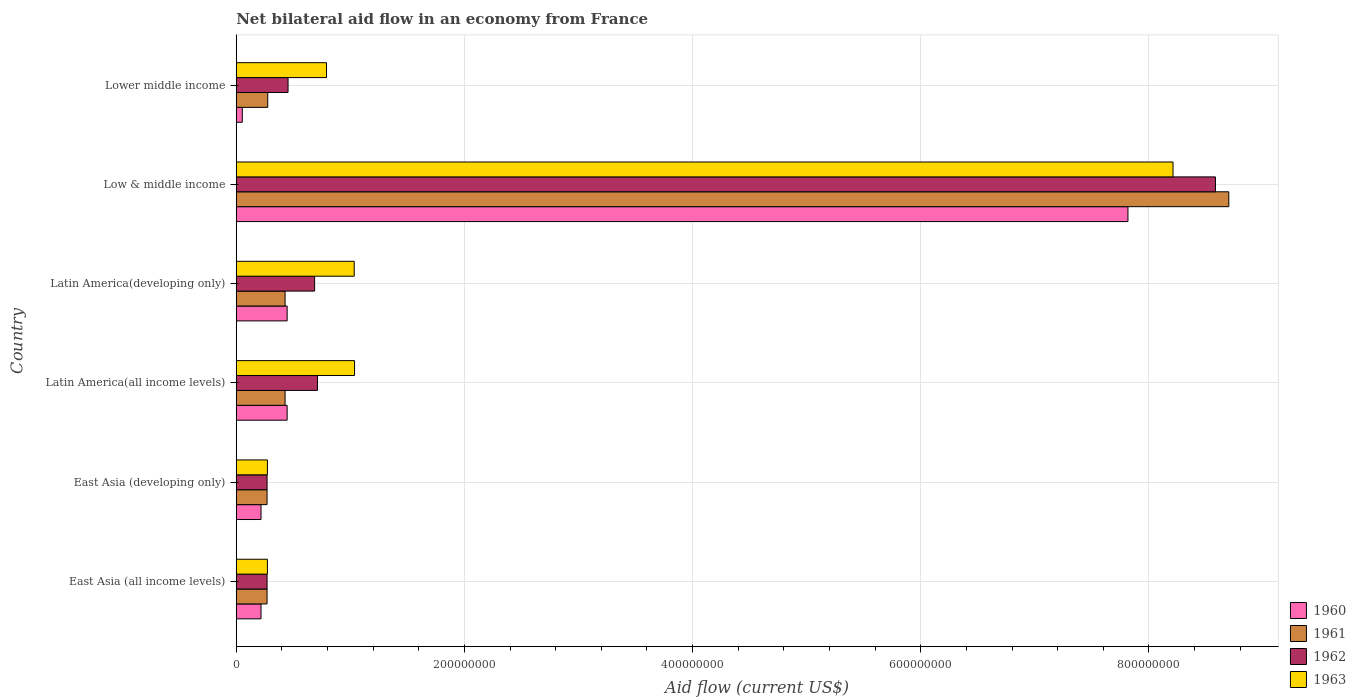Are the number of bars per tick equal to the number of legend labels?
Keep it short and to the point. Yes. Are the number of bars on each tick of the Y-axis equal?
Offer a very short reply. Yes. How many bars are there on the 2nd tick from the top?
Ensure brevity in your answer.  4. What is the label of the 6th group of bars from the top?
Your response must be concise. East Asia (all income levels). What is the net bilateral aid flow in 1960 in Latin America(developing only)?
Ensure brevity in your answer.  4.46e+07. Across all countries, what is the maximum net bilateral aid flow in 1963?
Make the answer very short. 8.21e+08. Across all countries, what is the minimum net bilateral aid flow in 1963?
Give a very brief answer. 2.73e+07. In which country was the net bilateral aid flow in 1962 maximum?
Keep it short and to the point. Low & middle income. In which country was the net bilateral aid flow in 1962 minimum?
Keep it short and to the point. East Asia (all income levels). What is the total net bilateral aid flow in 1960 in the graph?
Make the answer very short. 9.20e+08. What is the difference between the net bilateral aid flow in 1963 in Latin America(all income levels) and that in Latin America(developing only)?
Keep it short and to the point. 3.00e+05. What is the difference between the net bilateral aid flow in 1963 in Latin America(all income levels) and the net bilateral aid flow in 1961 in East Asia (developing only)?
Ensure brevity in your answer.  7.67e+07. What is the average net bilateral aid flow in 1961 per country?
Offer a terse response. 1.73e+08. What is the difference between the net bilateral aid flow in 1963 and net bilateral aid flow in 1960 in East Asia (all income levels)?
Your answer should be very brief. 5.60e+06. What is the ratio of the net bilateral aid flow in 1963 in Latin America(all income levels) to that in Lower middle income?
Your response must be concise. 1.31. Is the net bilateral aid flow in 1963 in Latin America(all income levels) less than that in Lower middle income?
Make the answer very short. No. What is the difference between the highest and the second highest net bilateral aid flow in 1962?
Offer a very short reply. 7.87e+08. What is the difference between the highest and the lowest net bilateral aid flow in 1961?
Give a very brief answer. 8.43e+08. Is the sum of the net bilateral aid flow in 1962 in Latin America(all income levels) and Lower middle income greater than the maximum net bilateral aid flow in 1963 across all countries?
Your answer should be compact. No. Is it the case that in every country, the sum of the net bilateral aid flow in 1963 and net bilateral aid flow in 1961 is greater than the sum of net bilateral aid flow in 1962 and net bilateral aid flow in 1960?
Provide a short and direct response. Yes. What does the 3rd bar from the top in Latin America(developing only) represents?
Give a very brief answer. 1961. What does the 3rd bar from the bottom in East Asia (developing only) represents?
Provide a succinct answer. 1962. How many countries are there in the graph?
Provide a succinct answer. 6. Where does the legend appear in the graph?
Your answer should be compact. Bottom right. How many legend labels are there?
Your answer should be compact. 4. What is the title of the graph?
Your answer should be compact. Net bilateral aid flow in an economy from France. What is the label or title of the Y-axis?
Ensure brevity in your answer.  Country. What is the Aid flow (current US$) of 1960 in East Asia (all income levels)?
Your response must be concise. 2.17e+07. What is the Aid flow (current US$) in 1961 in East Asia (all income levels)?
Provide a succinct answer. 2.70e+07. What is the Aid flow (current US$) in 1962 in East Asia (all income levels)?
Keep it short and to the point. 2.70e+07. What is the Aid flow (current US$) of 1963 in East Asia (all income levels)?
Give a very brief answer. 2.73e+07. What is the Aid flow (current US$) in 1960 in East Asia (developing only)?
Make the answer very short. 2.17e+07. What is the Aid flow (current US$) in 1961 in East Asia (developing only)?
Your response must be concise. 2.70e+07. What is the Aid flow (current US$) in 1962 in East Asia (developing only)?
Ensure brevity in your answer.  2.70e+07. What is the Aid flow (current US$) in 1963 in East Asia (developing only)?
Offer a very short reply. 2.73e+07. What is the Aid flow (current US$) in 1960 in Latin America(all income levels)?
Offer a very short reply. 4.46e+07. What is the Aid flow (current US$) of 1961 in Latin America(all income levels)?
Your answer should be compact. 4.28e+07. What is the Aid flow (current US$) in 1962 in Latin America(all income levels)?
Offer a very short reply. 7.12e+07. What is the Aid flow (current US$) in 1963 in Latin America(all income levels)?
Offer a terse response. 1.04e+08. What is the Aid flow (current US$) of 1960 in Latin America(developing only)?
Ensure brevity in your answer.  4.46e+07. What is the Aid flow (current US$) of 1961 in Latin America(developing only)?
Give a very brief answer. 4.28e+07. What is the Aid flow (current US$) of 1962 in Latin America(developing only)?
Your response must be concise. 6.87e+07. What is the Aid flow (current US$) in 1963 in Latin America(developing only)?
Your answer should be very brief. 1.03e+08. What is the Aid flow (current US$) of 1960 in Low & middle income?
Offer a very short reply. 7.82e+08. What is the Aid flow (current US$) of 1961 in Low & middle income?
Make the answer very short. 8.70e+08. What is the Aid flow (current US$) of 1962 in Low & middle income?
Give a very brief answer. 8.58e+08. What is the Aid flow (current US$) of 1963 in Low & middle income?
Your answer should be very brief. 8.21e+08. What is the Aid flow (current US$) in 1960 in Lower middle income?
Give a very brief answer. 5.30e+06. What is the Aid flow (current US$) in 1961 in Lower middle income?
Provide a succinct answer. 2.76e+07. What is the Aid flow (current US$) in 1962 in Lower middle income?
Offer a terse response. 4.54e+07. What is the Aid flow (current US$) in 1963 in Lower middle income?
Offer a very short reply. 7.91e+07. Across all countries, what is the maximum Aid flow (current US$) of 1960?
Your response must be concise. 7.82e+08. Across all countries, what is the maximum Aid flow (current US$) of 1961?
Your response must be concise. 8.70e+08. Across all countries, what is the maximum Aid flow (current US$) of 1962?
Your answer should be compact. 8.58e+08. Across all countries, what is the maximum Aid flow (current US$) in 1963?
Keep it short and to the point. 8.21e+08. Across all countries, what is the minimum Aid flow (current US$) of 1960?
Give a very brief answer. 5.30e+06. Across all countries, what is the minimum Aid flow (current US$) in 1961?
Your answer should be compact. 2.70e+07. Across all countries, what is the minimum Aid flow (current US$) of 1962?
Make the answer very short. 2.70e+07. Across all countries, what is the minimum Aid flow (current US$) of 1963?
Keep it short and to the point. 2.73e+07. What is the total Aid flow (current US$) of 1960 in the graph?
Your answer should be compact. 9.20e+08. What is the total Aid flow (current US$) of 1961 in the graph?
Your answer should be very brief. 1.04e+09. What is the total Aid flow (current US$) in 1962 in the graph?
Provide a short and direct response. 1.10e+09. What is the total Aid flow (current US$) of 1963 in the graph?
Your response must be concise. 1.16e+09. What is the difference between the Aid flow (current US$) in 1960 in East Asia (all income levels) and that in East Asia (developing only)?
Keep it short and to the point. 0. What is the difference between the Aid flow (current US$) in 1960 in East Asia (all income levels) and that in Latin America(all income levels)?
Make the answer very short. -2.29e+07. What is the difference between the Aid flow (current US$) of 1961 in East Asia (all income levels) and that in Latin America(all income levels)?
Offer a very short reply. -1.58e+07. What is the difference between the Aid flow (current US$) in 1962 in East Asia (all income levels) and that in Latin America(all income levels)?
Offer a terse response. -4.42e+07. What is the difference between the Aid flow (current US$) in 1963 in East Asia (all income levels) and that in Latin America(all income levels)?
Give a very brief answer. -7.64e+07. What is the difference between the Aid flow (current US$) in 1960 in East Asia (all income levels) and that in Latin America(developing only)?
Ensure brevity in your answer.  -2.29e+07. What is the difference between the Aid flow (current US$) of 1961 in East Asia (all income levels) and that in Latin America(developing only)?
Provide a short and direct response. -1.58e+07. What is the difference between the Aid flow (current US$) in 1962 in East Asia (all income levels) and that in Latin America(developing only)?
Make the answer very short. -4.17e+07. What is the difference between the Aid flow (current US$) in 1963 in East Asia (all income levels) and that in Latin America(developing only)?
Make the answer very short. -7.61e+07. What is the difference between the Aid flow (current US$) in 1960 in East Asia (all income levels) and that in Low & middle income?
Offer a very short reply. -7.60e+08. What is the difference between the Aid flow (current US$) in 1961 in East Asia (all income levels) and that in Low & middle income?
Ensure brevity in your answer.  -8.43e+08. What is the difference between the Aid flow (current US$) in 1962 in East Asia (all income levels) and that in Low & middle income?
Give a very brief answer. -8.31e+08. What is the difference between the Aid flow (current US$) of 1963 in East Asia (all income levels) and that in Low & middle income?
Provide a short and direct response. -7.94e+08. What is the difference between the Aid flow (current US$) in 1960 in East Asia (all income levels) and that in Lower middle income?
Keep it short and to the point. 1.64e+07. What is the difference between the Aid flow (current US$) in 1961 in East Asia (all income levels) and that in Lower middle income?
Your answer should be compact. -6.00e+05. What is the difference between the Aid flow (current US$) in 1962 in East Asia (all income levels) and that in Lower middle income?
Make the answer very short. -1.84e+07. What is the difference between the Aid flow (current US$) in 1963 in East Asia (all income levels) and that in Lower middle income?
Give a very brief answer. -5.18e+07. What is the difference between the Aid flow (current US$) of 1960 in East Asia (developing only) and that in Latin America(all income levels)?
Give a very brief answer. -2.29e+07. What is the difference between the Aid flow (current US$) in 1961 in East Asia (developing only) and that in Latin America(all income levels)?
Provide a succinct answer. -1.58e+07. What is the difference between the Aid flow (current US$) in 1962 in East Asia (developing only) and that in Latin America(all income levels)?
Offer a terse response. -4.42e+07. What is the difference between the Aid flow (current US$) in 1963 in East Asia (developing only) and that in Latin America(all income levels)?
Keep it short and to the point. -7.64e+07. What is the difference between the Aid flow (current US$) of 1960 in East Asia (developing only) and that in Latin America(developing only)?
Provide a short and direct response. -2.29e+07. What is the difference between the Aid flow (current US$) in 1961 in East Asia (developing only) and that in Latin America(developing only)?
Make the answer very short. -1.58e+07. What is the difference between the Aid flow (current US$) of 1962 in East Asia (developing only) and that in Latin America(developing only)?
Ensure brevity in your answer.  -4.17e+07. What is the difference between the Aid flow (current US$) in 1963 in East Asia (developing only) and that in Latin America(developing only)?
Give a very brief answer. -7.61e+07. What is the difference between the Aid flow (current US$) of 1960 in East Asia (developing only) and that in Low & middle income?
Your response must be concise. -7.60e+08. What is the difference between the Aid flow (current US$) in 1961 in East Asia (developing only) and that in Low & middle income?
Provide a short and direct response. -8.43e+08. What is the difference between the Aid flow (current US$) in 1962 in East Asia (developing only) and that in Low & middle income?
Make the answer very short. -8.31e+08. What is the difference between the Aid flow (current US$) in 1963 in East Asia (developing only) and that in Low & middle income?
Your answer should be compact. -7.94e+08. What is the difference between the Aid flow (current US$) in 1960 in East Asia (developing only) and that in Lower middle income?
Your answer should be compact. 1.64e+07. What is the difference between the Aid flow (current US$) of 1961 in East Asia (developing only) and that in Lower middle income?
Give a very brief answer. -6.00e+05. What is the difference between the Aid flow (current US$) in 1962 in East Asia (developing only) and that in Lower middle income?
Offer a terse response. -1.84e+07. What is the difference between the Aid flow (current US$) of 1963 in East Asia (developing only) and that in Lower middle income?
Offer a very short reply. -5.18e+07. What is the difference between the Aid flow (current US$) in 1960 in Latin America(all income levels) and that in Latin America(developing only)?
Make the answer very short. 0. What is the difference between the Aid flow (current US$) of 1961 in Latin America(all income levels) and that in Latin America(developing only)?
Provide a short and direct response. 0. What is the difference between the Aid flow (current US$) of 1962 in Latin America(all income levels) and that in Latin America(developing only)?
Ensure brevity in your answer.  2.50e+06. What is the difference between the Aid flow (current US$) of 1960 in Latin America(all income levels) and that in Low & middle income?
Make the answer very short. -7.37e+08. What is the difference between the Aid flow (current US$) of 1961 in Latin America(all income levels) and that in Low & middle income?
Offer a terse response. -8.27e+08. What is the difference between the Aid flow (current US$) of 1962 in Latin America(all income levels) and that in Low & middle income?
Make the answer very short. -7.87e+08. What is the difference between the Aid flow (current US$) of 1963 in Latin America(all income levels) and that in Low & middle income?
Provide a succinct answer. -7.17e+08. What is the difference between the Aid flow (current US$) in 1960 in Latin America(all income levels) and that in Lower middle income?
Offer a very short reply. 3.93e+07. What is the difference between the Aid flow (current US$) in 1961 in Latin America(all income levels) and that in Lower middle income?
Keep it short and to the point. 1.52e+07. What is the difference between the Aid flow (current US$) in 1962 in Latin America(all income levels) and that in Lower middle income?
Keep it short and to the point. 2.58e+07. What is the difference between the Aid flow (current US$) in 1963 in Latin America(all income levels) and that in Lower middle income?
Your response must be concise. 2.46e+07. What is the difference between the Aid flow (current US$) in 1960 in Latin America(developing only) and that in Low & middle income?
Provide a succinct answer. -7.37e+08. What is the difference between the Aid flow (current US$) of 1961 in Latin America(developing only) and that in Low & middle income?
Give a very brief answer. -8.27e+08. What is the difference between the Aid flow (current US$) of 1962 in Latin America(developing only) and that in Low & middle income?
Ensure brevity in your answer.  -7.90e+08. What is the difference between the Aid flow (current US$) of 1963 in Latin America(developing only) and that in Low & middle income?
Provide a short and direct response. -7.18e+08. What is the difference between the Aid flow (current US$) of 1960 in Latin America(developing only) and that in Lower middle income?
Give a very brief answer. 3.93e+07. What is the difference between the Aid flow (current US$) in 1961 in Latin America(developing only) and that in Lower middle income?
Offer a terse response. 1.52e+07. What is the difference between the Aid flow (current US$) of 1962 in Latin America(developing only) and that in Lower middle income?
Offer a very short reply. 2.33e+07. What is the difference between the Aid flow (current US$) of 1963 in Latin America(developing only) and that in Lower middle income?
Your response must be concise. 2.43e+07. What is the difference between the Aid flow (current US$) in 1960 in Low & middle income and that in Lower middle income?
Provide a short and direct response. 7.76e+08. What is the difference between the Aid flow (current US$) of 1961 in Low & middle income and that in Lower middle income?
Offer a very short reply. 8.42e+08. What is the difference between the Aid flow (current US$) in 1962 in Low & middle income and that in Lower middle income?
Your answer should be very brief. 8.13e+08. What is the difference between the Aid flow (current US$) of 1963 in Low & middle income and that in Lower middle income?
Keep it short and to the point. 7.42e+08. What is the difference between the Aid flow (current US$) of 1960 in East Asia (all income levels) and the Aid flow (current US$) of 1961 in East Asia (developing only)?
Offer a very short reply. -5.30e+06. What is the difference between the Aid flow (current US$) in 1960 in East Asia (all income levels) and the Aid flow (current US$) in 1962 in East Asia (developing only)?
Ensure brevity in your answer.  -5.30e+06. What is the difference between the Aid flow (current US$) in 1960 in East Asia (all income levels) and the Aid flow (current US$) in 1963 in East Asia (developing only)?
Provide a succinct answer. -5.60e+06. What is the difference between the Aid flow (current US$) of 1961 in East Asia (all income levels) and the Aid flow (current US$) of 1963 in East Asia (developing only)?
Offer a very short reply. -3.00e+05. What is the difference between the Aid flow (current US$) in 1962 in East Asia (all income levels) and the Aid flow (current US$) in 1963 in East Asia (developing only)?
Provide a succinct answer. -3.00e+05. What is the difference between the Aid flow (current US$) in 1960 in East Asia (all income levels) and the Aid flow (current US$) in 1961 in Latin America(all income levels)?
Give a very brief answer. -2.11e+07. What is the difference between the Aid flow (current US$) of 1960 in East Asia (all income levels) and the Aid flow (current US$) of 1962 in Latin America(all income levels)?
Give a very brief answer. -4.95e+07. What is the difference between the Aid flow (current US$) in 1960 in East Asia (all income levels) and the Aid flow (current US$) in 1963 in Latin America(all income levels)?
Your response must be concise. -8.20e+07. What is the difference between the Aid flow (current US$) in 1961 in East Asia (all income levels) and the Aid flow (current US$) in 1962 in Latin America(all income levels)?
Your answer should be very brief. -4.42e+07. What is the difference between the Aid flow (current US$) of 1961 in East Asia (all income levels) and the Aid flow (current US$) of 1963 in Latin America(all income levels)?
Keep it short and to the point. -7.67e+07. What is the difference between the Aid flow (current US$) in 1962 in East Asia (all income levels) and the Aid flow (current US$) in 1963 in Latin America(all income levels)?
Keep it short and to the point. -7.67e+07. What is the difference between the Aid flow (current US$) in 1960 in East Asia (all income levels) and the Aid flow (current US$) in 1961 in Latin America(developing only)?
Provide a short and direct response. -2.11e+07. What is the difference between the Aid flow (current US$) in 1960 in East Asia (all income levels) and the Aid flow (current US$) in 1962 in Latin America(developing only)?
Offer a terse response. -4.70e+07. What is the difference between the Aid flow (current US$) of 1960 in East Asia (all income levels) and the Aid flow (current US$) of 1963 in Latin America(developing only)?
Offer a very short reply. -8.17e+07. What is the difference between the Aid flow (current US$) in 1961 in East Asia (all income levels) and the Aid flow (current US$) in 1962 in Latin America(developing only)?
Provide a succinct answer. -4.17e+07. What is the difference between the Aid flow (current US$) of 1961 in East Asia (all income levels) and the Aid flow (current US$) of 1963 in Latin America(developing only)?
Ensure brevity in your answer.  -7.64e+07. What is the difference between the Aid flow (current US$) in 1962 in East Asia (all income levels) and the Aid flow (current US$) in 1963 in Latin America(developing only)?
Provide a succinct answer. -7.64e+07. What is the difference between the Aid flow (current US$) in 1960 in East Asia (all income levels) and the Aid flow (current US$) in 1961 in Low & middle income?
Provide a succinct answer. -8.48e+08. What is the difference between the Aid flow (current US$) in 1960 in East Asia (all income levels) and the Aid flow (current US$) in 1962 in Low & middle income?
Give a very brief answer. -8.37e+08. What is the difference between the Aid flow (current US$) in 1960 in East Asia (all income levels) and the Aid flow (current US$) in 1963 in Low & middle income?
Provide a succinct answer. -7.99e+08. What is the difference between the Aid flow (current US$) of 1961 in East Asia (all income levels) and the Aid flow (current US$) of 1962 in Low & middle income?
Give a very brief answer. -8.31e+08. What is the difference between the Aid flow (current US$) in 1961 in East Asia (all income levels) and the Aid flow (current US$) in 1963 in Low & middle income?
Provide a short and direct response. -7.94e+08. What is the difference between the Aid flow (current US$) in 1962 in East Asia (all income levels) and the Aid flow (current US$) in 1963 in Low & middle income?
Your answer should be compact. -7.94e+08. What is the difference between the Aid flow (current US$) of 1960 in East Asia (all income levels) and the Aid flow (current US$) of 1961 in Lower middle income?
Provide a succinct answer. -5.90e+06. What is the difference between the Aid flow (current US$) in 1960 in East Asia (all income levels) and the Aid flow (current US$) in 1962 in Lower middle income?
Ensure brevity in your answer.  -2.37e+07. What is the difference between the Aid flow (current US$) of 1960 in East Asia (all income levels) and the Aid flow (current US$) of 1963 in Lower middle income?
Keep it short and to the point. -5.74e+07. What is the difference between the Aid flow (current US$) of 1961 in East Asia (all income levels) and the Aid flow (current US$) of 1962 in Lower middle income?
Ensure brevity in your answer.  -1.84e+07. What is the difference between the Aid flow (current US$) of 1961 in East Asia (all income levels) and the Aid flow (current US$) of 1963 in Lower middle income?
Keep it short and to the point. -5.21e+07. What is the difference between the Aid flow (current US$) of 1962 in East Asia (all income levels) and the Aid flow (current US$) of 1963 in Lower middle income?
Provide a succinct answer. -5.21e+07. What is the difference between the Aid flow (current US$) of 1960 in East Asia (developing only) and the Aid flow (current US$) of 1961 in Latin America(all income levels)?
Provide a succinct answer. -2.11e+07. What is the difference between the Aid flow (current US$) in 1960 in East Asia (developing only) and the Aid flow (current US$) in 1962 in Latin America(all income levels)?
Your response must be concise. -4.95e+07. What is the difference between the Aid flow (current US$) of 1960 in East Asia (developing only) and the Aid flow (current US$) of 1963 in Latin America(all income levels)?
Offer a terse response. -8.20e+07. What is the difference between the Aid flow (current US$) in 1961 in East Asia (developing only) and the Aid flow (current US$) in 1962 in Latin America(all income levels)?
Keep it short and to the point. -4.42e+07. What is the difference between the Aid flow (current US$) of 1961 in East Asia (developing only) and the Aid flow (current US$) of 1963 in Latin America(all income levels)?
Your response must be concise. -7.67e+07. What is the difference between the Aid flow (current US$) of 1962 in East Asia (developing only) and the Aid flow (current US$) of 1963 in Latin America(all income levels)?
Ensure brevity in your answer.  -7.67e+07. What is the difference between the Aid flow (current US$) in 1960 in East Asia (developing only) and the Aid flow (current US$) in 1961 in Latin America(developing only)?
Provide a short and direct response. -2.11e+07. What is the difference between the Aid flow (current US$) of 1960 in East Asia (developing only) and the Aid flow (current US$) of 1962 in Latin America(developing only)?
Ensure brevity in your answer.  -4.70e+07. What is the difference between the Aid flow (current US$) of 1960 in East Asia (developing only) and the Aid flow (current US$) of 1963 in Latin America(developing only)?
Ensure brevity in your answer.  -8.17e+07. What is the difference between the Aid flow (current US$) in 1961 in East Asia (developing only) and the Aid flow (current US$) in 1962 in Latin America(developing only)?
Give a very brief answer. -4.17e+07. What is the difference between the Aid flow (current US$) of 1961 in East Asia (developing only) and the Aid flow (current US$) of 1963 in Latin America(developing only)?
Keep it short and to the point. -7.64e+07. What is the difference between the Aid flow (current US$) of 1962 in East Asia (developing only) and the Aid flow (current US$) of 1963 in Latin America(developing only)?
Your answer should be compact. -7.64e+07. What is the difference between the Aid flow (current US$) of 1960 in East Asia (developing only) and the Aid flow (current US$) of 1961 in Low & middle income?
Provide a succinct answer. -8.48e+08. What is the difference between the Aid flow (current US$) of 1960 in East Asia (developing only) and the Aid flow (current US$) of 1962 in Low & middle income?
Your response must be concise. -8.37e+08. What is the difference between the Aid flow (current US$) of 1960 in East Asia (developing only) and the Aid flow (current US$) of 1963 in Low & middle income?
Your answer should be very brief. -7.99e+08. What is the difference between the Aid flow (current US$) of 1961 in East Asia (developing only) and the Aid flow (current US$) of 1962 in Low & middle income?
Provide a succinct answer. -8.31e+08. What is the difference between the Aid flow (current US$) of 1961 in East Asia (developing only) and the Aid flow (current US$) of 1963 in Low & middle income?
Ensure brevity in your answer.  -7.94e+08. What is the difference between the Aid flow (current US$) in 1962 in East Asia (developing only) and the Aid flow (current US$) in 1963 in Low & middle income?
Provide a short and direct response. -7.94e+08. What is the difference between the Aid flow (current US$) in 1960 in East Asia (developing only) and the Aid flow (current US$) in 1961 in Lower middle income?
Offer a very short reply. -5.90e+06. What is the difference between the Aid flow (current US$) in 1960 in East Asia (developing only) and the Aid flow (current US$) in 1962 in Lower middle income?
Keep it short and to the point. -2.37e+07. What is the difference between the Aid flow (current US$) in 1960 in East Asia (developing only) and the Aid flow (current US$) in 1963 in Lower middle income?
Offer a terse response. -5.74e+07. What is the difference between the Aid flow (current US$) in 1961 in East Asia (developing only) and the Aid flow (current US$) in 1962 in Lower middle income?
Ensure brevity in your answer.  -1.84e+07. What is the difference between the Aid flow (current US$) of 1961 in East Asia (developing only) and the Aid flow (current US$) of 1963 in Lower middle income?
Your answer should be compact. -5.21e+07. What is the difference between the Aid flow (current US$) in 1962 in East Asia (developing only) and the Aid flow (current US$) in 1963 in Lower middle income?
Ensure brevity in your answer.  -5.21e+07. What is the difference between the Aid flow (current US$) in 1960 in Latin America(all income levels) and the Aid flow (current US$) in 1961 in Latin America(developing only)?
Make the answer very short. 1.80e+06. What is the difference between the Aid flow (current US$) in 1960 in Latin America(all income levels) and the Aid flow (current US$) in 1962 in Latin America(developing only)?
Your response must be concise. -2.41e+07. What is the difference between the Aid flow (current US$) in 1960 in Latin America(all income levels) and the Aid flow (current US$) in 1963 in Latin America(developing only)?
Offer a very short reply. -5.88e+07. What is the difference between the Aid flow (current US$) in 1961 in Latin America(all income levels) and the Aid flow (current US$) in 1962 in Latin America(developing only)?
Offer a terse response. -2.59e+07. What is the difference between the Aid flow (current US$) of 1961 in Latin America(all income levels) and the Aid flow (current US$) of 1963 in Latin America(developing only)?
Ensure brevity in your answer.  -6.06e+07. What is the difference between the Aid flow (current US$) in 1962 in Latin America(all income levels) and the Aid flow (current US$) in 1963 in Latin America(developing only)?
Make the answer very short. -3.22e+07. What is the difference between the Aid flow (current US$) of 1960 in Latin America(all income levels) and the Aid flow (current US$) of 1961 in Low & middle income?
Keep it short and to the point. -8.25e+08. What is the difference between the Aid flow (current US$) of 1960 in Latin America(all income levels) and the Aid flow (current US$) of 1962 in Low & middle income?
Provide a short and direct response. -8.14e+08. What is the difference between the Aid flow (current US$) of 1960 in Latin America(all income levels) and the Aid flow (current US$) of 1963 in Low & middle income?
Your answer should be compact. -7.76e+08. What is the difference between the Aid flow (current US$) in 1961 in Latin America(all income levels) and the Aid flow (current US$) in 1962 in Low & middle income?
Provide a short and direct response. -8.16e+08. What is the difference between the Aid flow (current US$) in 1961 in Latin America(all income levels) and the Aid flow (current US$) in 1963 in Low & middle income?
Ensure brevity in your answer.  -7.78e+08. What is the difference between the Aid flow (current US$) in 1962 in Latin America(all income levels) and the Aid flow (current US$) in 1963 in Low & middle income?
Your answer should be very brief. -7.50e+08. What is the difference between the Aid flow (current US$) in 1960 in Latin America(all income levels) and the Aid flow (current US$) in 1961 in Lower middle income?
Offer a terse response. 1.70e+07. What is the difference between the Aid flow (current US$) of 1960 in Latin America(all income levels) and the Aid flow (current US$) of 1962 in Lower middle income?
Keep it short and to the point. -8.00e+05. What is the difference between the Aid flow (current US$) of 1960 in Latin America(all income levels) and the Aid flow (current US$) of 1963 in Lower middle income?
Your response must be concise. -3.45e+07. What is the difference between the Aid flow (current US$) in 1961 in Latin America(all income levels) and the Aid flow (current US$) in 1962 in Lower middle income?
Provide a short and direct response. -2.60e+06. What is the difference between the Aid flow (current US$) in 1961 in Latin America(all income levels) and the Aid flow (current US$) in 1963 in Lower middle income?
Your answer should be very brief. -3.63e+07. What is the difference between the Aid flow (current US$) of 1962 in Latin America(all income levels) and the Aid flow (current US$) of 1963 in Lower middle income?
Offer a very short reply. -7.90e+06. What is the difference between the Aid flow (current US$) of 1960 in Latin America(developing only) and the Aid flow (current US$) of 1961 in Low & middle income?
Your answer should be compact. -8.25e+08. What is the difference between the Aid flow (current US$) in 1960 in Latin America(developing only) and the Aid flow (current US$) in 1962 in Low & middle income?
Your response must be concise. -8.14e+08. What is the difference between the Aid flow (current US$) of 1960 in Latin America(developing only) and the Aid flow (current US$) of 1963 in Low & middle income?
Your response must be concise. -7.76e+08. What is the difference between the Aid flow (current US$) of 1961 in Latin America(developing only) and the Aid flow (current US$) of 1962 in Low & middle income?
Provide a succinct answer. -8.16e+08. What is the difference between the Aid flow (current US$) in 1961 in Latin America(developing only) and the Aid flow (current US$) in 1963 in Low & middle income?
Ensure brevity in your answer.  -7.78e+08. What is the difference between the Aid flow (current US$) of 1962 in Latin America(developing only) and the Aid flow (current US$) of 1963 in Low & middle income?
Offer a terse response. -7.52e+08. What is the difference between the Aid flow (current US$) of 1960 in Latin America(developing only) and the Aid flow (current US$) of 1961 in Lower middle income?
Give a very brief answer. 1.70e+07. What is the difference between the Aid flow (current US$) in 1960 in Latin America(developing only) and the Aid flow (current US$) in 1962 in Lower middle income?
Keep it short and to the point. -8.00e+05. What is the difference between the Aid flow (current US$) of 1960 in Latin America(developing only) and the Aid flow (current US$) of 1963 in Lower middle income?
Give a very brief answer. -3.45e+07. What is the difference between the Aid flow (current US$) in 1961 in Latin America(developing only) and the Aid flow (current US$) in 1962 in Lower middle income?
Provide a succinct answer. -2.60e+06. What is the difference between the Aid flow (current US$) in 1961 in Latin America(developing only) and the Aid flow (current US$) in 1963 in Lower middle income?
Make the answer very short. -3.63e+07. What is the difference between the Aid flow (current US$) in 1962 in Latin America(developing only) and the Aid flow (current US$) in 1963 in Lower middle income?
Your answer should be very brief. -1.04e+07. What is the difference between the Aid flow (current US$) in 1960 in Low & middle income and the Aid flow (current US$) in 1961 in Lower middle income?
Ensure brevity in your answer.  7.54e+08. What is the difference between the Aid flow (current US$) in 1960 in Low & middle income and the Aid flow (current US$) in 1962 in Lower middle income?
Offer a terse response. 7.36e+08. What is the difference between the Aid flow (current US$) in 1960 in Low & middle income and the Aid flow (current US$) in 1963 in Lower middle income?
Provide a succinct answer. 7.02e+08. What is the difference between the Aid flow (current US$) in 1961 in Low & middle income and the Aid flow (current US$) in 1962 in Lower middle income?
Your answer should be compact. 8.25e+08. What is the difference between the Aid flow (current US$) in 1961 in Low & middle income and the Aid flow (current US$) in 1963 in Lower middle income?
Make the answer very short. 7.91e+08. What is the difference between the Aid flow (current US$) in 1962 in Low & middle income and the Aid flow (current US$) in 1963 in Lower middle income?
Make the answer very short. 7.79e+08. What is the average Aid flow (current US$) in 1960 per country?
Make the answer very short. 1.53e+08. What is the average Aid flow (current US$) of 1961 per country?
Offer a terse response. 1.73e+08. What is the average Aid flow (current US$) of 1962 per country?
Your answer should be very brief. 1.83e+08. What is the average Aid flow (current US$) in 1963 per country?
Provide a succinct answer. 1.94e+08. What is the difference between the Aid flow (current US$) of 1960 and Aid flow (current US$) of 1961 in East Asia (all income levels)?
Your answer should be very brief. -5.30e+06. What is the difference between the Aid flow (current US$) of 1960 and Aid flow (current US$) of 1962 in East Asia (all income levels)?
Make the answer very short. -5.30e+06. What is the difference between the Aid flow (current US$) in 1960 and Aid flow (current US$) in 1963 in East Asia (all income levels)?
Keep it short and to the point. -5.60e+06. What is the difference between the Aid flow (current US$) in 1961 and Aid flow (current US$) in 1963 in East Asia (all income levels)?
Ensure brevity in your answer.  -3.00e+05. What is the difference between the Aid flow (current US$) of 1960 and Aid flow (current US$) of 1961 in East Asia (developing only)?
Your response must be concise. -5.30e+06. What is the difference between the Aid flow (current US$) of 1960 and Aid flow (current US$) of 1962 in East Asia (developing only)?
Make the answer very short. -5.30e+06. What is the difference between the Aid flow (current US$) of 1960 and Aid flow (current US$) of 1963 in East Asia (developing only)?
Your response must be concise. -5.60e+06. What is the difference between the Aid flow (current US$) in 1962 and Aid flow (current US$) in 1963 in East Asia (developing only)?
Make the answer very short. -3.00e+05. What is the difference between the Aid flow (current US$) of 1960 and Aid flow (current US$) of 1961 in Latin America(all income levels)?
Offer a terse response. 1.80e+06. What is the difference between the Aid flow (current US$) in 1960 and Aid flow (current US$) in 1962 in Latin America(all income levels)?
Keep it short and to the point. -2.66e+07. What is the difference between the Aid flow (current US$) of 1960 and Aid flow (current US$) of 1963 in Latin America(all income levels)?
Give a very brief answer. -5.91e+07. What is the difference between the Aid flow (current US$) of 1961 and Aid flow (current US$) of 1962 in Latin America(all income levels)?
Offer a very short reply. -2.84e+07. What is the difference between the Aid flow (current US$) in 1961 and Aid flow (current US$) in 1963 in Latin America(all income levels)?
Keep it short and to the point. -6.09e+07. What is the difference between the Aid flow (current US$) in 1962 and Aid flow (current US$) in 1963 in Latin America(all income levels)?
Provide a short and direct response. -3.25e+07. What is the difference between the Aid flow (current US$) in 1960 and Aid flow (current US$) in 1961 in Latin America(developing only)?
Keep it short and to the point. 1.80e+06. What is the difference between the Aid flow (current US$) of 1960 and Aid flow (current US$) of 1962 in Latin America(developing only)?
Offer a very short reply. -2.41e+07. What is the difference between the Aid flow (current US$) in 1960 and Aid flow (current US$) in 1963 in Latin America(developing only)?
Give a very brief answer. -5.88e+07. What is the difference between the Aid flow (current US$) of 1961 and Aid flow (current US$) of 1962 in Latin America(developing only)?
Make the answer very short. -2.59e+07. What is the difference between the Aid flow (current US$) in 1961 and Aid flow (current US$) in 1963 in Latin America(developing only)?
Provide a succinct answer. -6.06e+07. What is the difference between the Aid flow (current US$) of 1962 and Aid flow (current US$) of 1963 in Latin America(developing only)?
Provide a short and direct response. -3.47e+07. What is the difference between the Aid flow (current US$) in 1960 and Aid flow (current US$) in 1961 in Low & middle income?
Give a very brief answer. -8.84e+07. What is the difference between the Aid flow (current US$) in 1960 and Aid flow (current US$) in 1962 in Low & middle income?
Your response must be concise. -7.67e+07. What is the difference between the Aid flow (current US$) of 1960 and Aid flow (current US$) of 1963 in Low & middle income?
Keep it short and to the point. -3.95e+07. What is the difference between the Aid flow (current US$) in 1961 and Aid flow (current US$) in 1962 in Low & middle income?
Give a very brief answer. 1.17e+07. What is the difference between the Aid flow (current US$) in 1961 and Aid flow (current US$) in 1963 in Low & middle income?
Your answer should be very brief. 4.89e+07. What is the difference between the Aid flow (current US$) in 1962 and Aid flow (current US$) in 1963 in Low & middle income?
Offer a terse response. 3.72e+07. What is the difference between the Aid flow (current US$) of 1960 and Aid flow (current US$) of 1961 in Lower middle income?
Your response must be concise. -2.23e+07. What is the difference between the Aid flow (current US$) in 1960 and Aid flow (current US$) in 1962 in Lower middle income?
Provide a succinct answer. -4.01e+07. What is the difference between the Aid flow (current US$) in 1960 and Aid flow (current US$) in 1963 in Lower middle income?
Offer a terse response. -7.38e+07. What is the difference between the Aid flow (current US$) of 1961 and Aid flow (current US$) of 1962 in Lower middle income?
Provide a succinct answer. -1.78e+07. What is the difference between the Aid flow (current US$) of 1961 and Aid flow (current US$) of 1963 in Lower middle income?
Provide a short and direct response. -5.15e+07. What is the difference between the Aid flow (current US$) in 1962 and Aid flow (current US$) in 1963 in Lower middle income?
Keep it short and to the point. -3.37e+07. What is the ratio of the Aid flow (current US$) in 1961 in East Asia (all income levels) to that in East Asia (developing only)?
Your answer should be very brief. 1. What is the ratio of the Aid flow (current US$) of 1962 in East Asia (all income levels) to that in East Asia (developing only)?
Give a very brief answer. 1. What is the ratio of the Aid flow (current US$) of 1960 in East Asia (all income levels) to that in Latin America(all income levels)?
Your answer should be compact. 0.49. What is the ratio of the Aid flow (current US$) of 1961 in East Asia (all income levels) to that in Latin America(all income levels)?
Keep it short and to the point. 0.63. What is the ratio of the Aid flow (current US$) in 1962 in East Asia (all income levels) to that in Latin America(all income levels)?
Keep it short and to the point. 0.38. What is the ratio of the Aid flow (current US$) of 1963 in East Asia (all income levels) to that in Latin America(all income levels)?
Give a very brief answer. 0.26. What is the ratio of the Aid flow (current US$) of 1960 in East Asia (all income levels) to that in Latin America(developing only)?
Offer a very short reply. 0.49. What is the ratio of the Aid flow (current US$) in 1961 in East Asia (all income levels) to that in Latin America(developing only)?
Your answer should be compact. 0.63. What is the ratio of the Aid flow (current US$) of 1962 in East Asia (all income levels) to that in Latin America(developing only)?
Make the answer very short. 0.39. What is the ratio of the Aid flow (current US$) of 1963 in East Asia (all income levels) to that in Latin America(developing only)?
Give a very brief answer. 0.26. What is the ratio of the Aid flow (current US$) in 1960 in East Asia (all income levels) to that in Low & middle income?
Provide a short and direct response. 0.03. What is the ratio of the Aid flow (current US$) of 1961 in East Asia (all income levels) to that in Low & middle income?
Your answer should be compact. 0.03. What is the ratio of the Aid flow (current US$) of 1962 in East Asia (all income levels) to that in Low & middle income?
Offer a terse response. 0.03. What is the ratio of the Aid flow (current US$) in 1963 in East Asia (all income levels) to that in Low & middle income?
Offer a terse response. 0.03. What is the ratio of the Aid flow (current US$) of 1960 in East Asia (all income levels) to that in Lower middle income?
Keep it short and to the point. 4.09. What is the ratio of the Aid flow (current US$) in 1961 in East Asia (all income levels) to that in Lower middle income?
Provide a short and direct response. 0.98. What is the ratio of the Aid flow (current US$) in 1962 in East Asia (all income levels) to that in Lower middle income?
Offer a very short reply. 0.59. What is the ratio of the Aid flow (current US$) of 1963 in East Asia (all income levels) to that in Lower middle income?
Keep it short and to the point. 0.35. What is the ratio of the Aid flow (current US$) in 1960 in East Asia (developing only) to that in Latin America(all income levels)?
Ensure brevity in your answer.  0.49. What is the ratio of the Aid flow (current US$) of 1961 in East Asia (developing only) to that in Latin America(all income levels)?
Ensure brevity in your answer.  0.63. What is the ratio of the Aid flow (current US$) in 1962 in East Asia (developing only) to that in Latin America(all income levels)?
Provide a short and direct response. 0.38. What is the ratio of the Aid flow (current US$) of 1963 in East Asia (developing only) to that in Latin America(all income levels)?
Provide a succinct answer. 0.26. What is the ratio of the Aid flow (current US$) in 1960 in East Asia (developing only) to that in Latin America(developing only)?
Provide a succinct answer. 0.49. What is the ratio of the Aid flow (current US$) of 1961 in East Asia (developing only) to that in Latin America(developing only)?
Provide a succinct answer. 0.63. What is the ratio of the Aid flow (current US$) in 1962 in East Asia (developing only) to that in Latin America(developing only)?
Keep it short and to the point. 0.39. What is the ratio of the Aid flow (current US$) of 1963 in East Asia (developing only) to that in Latin America(developing only)?
Ensure brevity in your answer.  0.26. What is the ratio of the Aid flow (current US$) in 1960 in East Asia (developing only) to that in Low & middle income?
Provide a short and direct response. 0.03. What is the ratio of the Aid flow (current US$) in 1961 in East Asia (developing only) to that in Low & middle income?
Offer a terse response. 0.03. What is the ratio of the Aid flow (current US$) in 1962 in East Asia (developing only) to that in Low & middle income?
Your answer should be very brief. 0.03. What is the ratio of the Aid flow (current US$) in 1963 in East Asia (developing only) to that in Low & middle income?
Your answer should be compact. 0.03. What is the ratio of the Aid flow (current US$) in 1960 in East Asia (developing only) to that in Lower middle income?
Your answer should be very brief. 4.09. What is the ratio of the Aid flow (current US$) of 1961 in East Asia (developing only) to that in Lower middle income?
Make the answer very short. 0.98. What is the ratio of the Aid flow (current US$) in 1962 in East Asia (developing only) to that in Lower middle income?
Keep it short and to the point. 0.59. What is the ratio of the Aid flow (current US$) in 1963 in East Asia (developing only) to that in Lower middle income?
Offer a terse response. 0.35. What is the ratio of the Aid flow (current US$) of 1960 in Latin America(all income levels) to that in Latin America(developing only)?
Keep it short and to the point. 1. What is the ratio of the Aid flow (current US$) in 1961 in Latin America(all income levels) to that in Latin America(developing only)?
Offer a very short reply. 1. What is the ratio of the Aid flow (current US$) of 1962 in Latin America(all income levels) to that in Latin America(developing only)?
Offer a very short reply. 1.04. What is the ratio of the Aid flow (current US$) of 1963 in Latin America(all income levels) to that in Latin America(developing only)?
Your answer should be compact. 1. What is the ratio of the Aid flow (current US$) of 1960 in Latin America(all income levels) to that in Low & middle income?
Give a very brief answer. 0.06. What is the ratio of the Aid flow (current US$) of 1961 in Latin America(all income levels) to that in Low & middle income?
Keep it short and to the point. 0.05. What is the ratio of the Aid flow (current US$) of 1962 in Latin America(all income levels) to that in Low & middle income?
Your answer should be very brief. 0.08. What is the ratio of the Aid flow (current US$) of 1963 in Latin America(all income levels) to that in Low & middle income?
Your response must be concise. 0.13. What is the ratio of the Aid flow (current US$) of 1960 in Latin America(all income levels) to that in Lower middle income?
Your response must be concise. 8.42. What is the ratio of the Aid flow (current US$) in 1961 in Latin America(all income levels) to that in Lower middle income?
Keep it short and to the point. 1.55. What is the ratio of the Aid flow (current US$) in 1962 in Latin America(all income levels) to that in Lower middle income?
Your answer should be compact. 1.57. What is the ratio of the Aid flow (current US$) of 1963 in Latin America(all income levels) to that in Lower middle income?
Offer a very short reply. 1.31. What is the ratio of the Aid flow (current US$) in 1960 in Latin America(developing only) to that in Low & middle income?
Your response must be concise. 0.06. What is the ratio of the Aid flow (current US$) of 1961 in Latin America(developing only) to that in Low & middle income?
Provide a short and direct response. 0.05. What is the ratio of the Aid flow (current US$) of 1963 in Latin America(developing only) to that in Low & middle income?
Ensure brevity in your answer.  0.13. What is the ratio of the Aid flow (current US$) of 1960 in Latin America(developing only) to that in Lower middle income?
Offer a terse response. 8.42. What is the ratio of the Aid flow (current US$) in 1961 in Latin America(developing only) to that in Lower middle income?
Provide a short and direct response. 1.55. What is the ratio of the Aid flow (current US$) in 1962 in Latin America(developing only) to that in Lower middle income?
Your response must be concise. 1.51. What is the ratio of the Aid flow (current US$) in 1963 in Latin America(developing only) to that in Lower middle income?
Your response must be concise. 1.31. What is the ratio of the Aid flow (current US$) in 1960 in Low & middle income to that in Lower middle income?
Offer a very short reply. 147.47. What is the ratio of the Aid flow (current US$) in 1961 in Low & middle income to that in Lower middle income?
Your answer should be very brief. 31.52. What is the ratio of the Aid flow (current US$) of 1962 in Low & middle income to that in Lower middle income?
Give a very brief answer. 18.91. What is the ratio of the Aid flow (current US$) of 1963 in Low & middle income to that in Lower middle income?
Provide a succinct answer. 10.38. What is the difference between the highest and the second highest Aid flow (current US$) in 1960?
Provide a short and direct response. 7.37e+08. What is the difference between the highest and the second highest Aid flow (current US$) of 1961?
Make the answer very short. 8.27e+08. What is the difference between the highest and the second highest Aid flow (current US$) of 1962?
Provide a short and direct response. 7.87e+08. What is the difference between the highest and the second highest Aid flow (current US$) of 1963?
Make the answer very short. 7.17e+08. What is the difference between the highest and the lowest Aid flow (current US$) of 1960?
Your answer should be compact. 7.76e+08. What is the difference between the highest and the lowest Aid flow (current US$) of 1961?
Ensure brevity in your answer.  8.43e+08. What is the difference between the highest and the lowest Aid flow (current US$) of 1962?
Keep it short and to the point. 8.31e+08. What is the difference between the highest and the lowest Aid flow (current US$) of 1963?
Keep it short and to the point. 7.94e+08. 